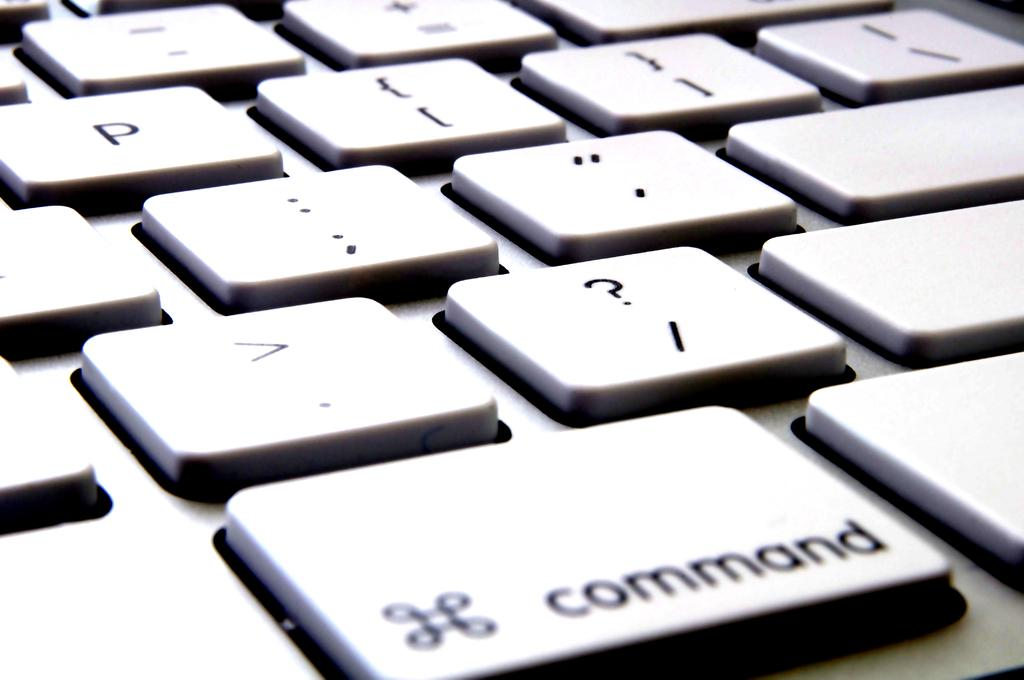<image>
Describe the image concisely. The command button of a keyboard is the largest key shown. 